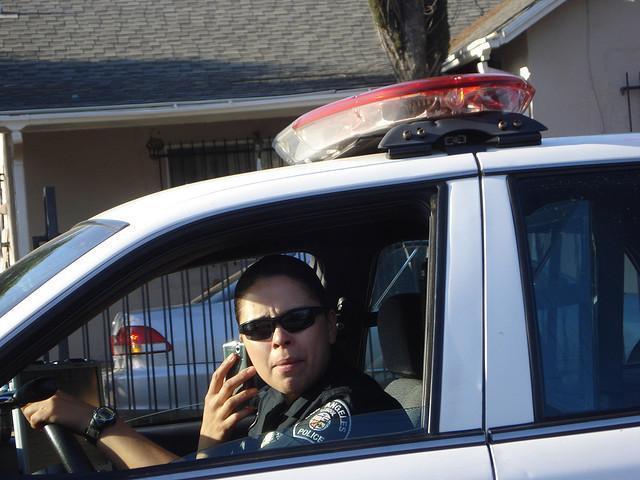How many windows can be seen on the house in the background?
Give a very brief answer. 1. How many cars are there?
Give a very brief answer. 1. 